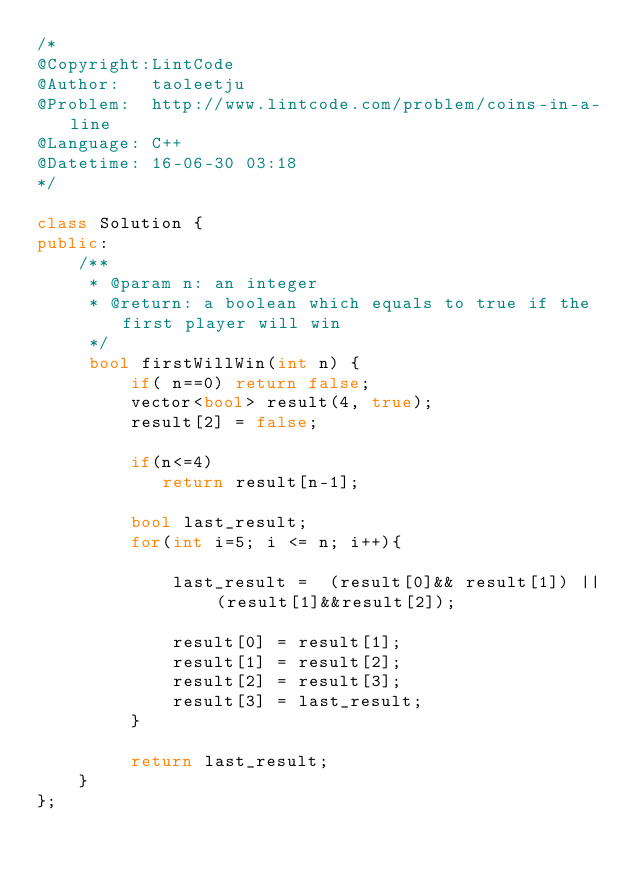<code> <loc_0><loc_0><loc_500><loc_500><_C++_>/*
@Copyright:LintCode
@Author:   taoleetju
@Problem:  http://www.lintcode.com/problem/coins-in-a-line
@Language: C++
@Datetime: 16-06-30 03:18
*/

class Solution {
public:
    /**
     * @param n: an integer
     * @return: a boolean which equals to true if the first player will win
     */
     bool firstWillWin(int n) {
         if( n==0) return false;
         vector<bool> result(4, true);
         result[2] = false;
        
         if(n<=4)
            return result[n-1];
        
         bool last_result;
         for(int i=5; i <= n; i++){
             
             last_result =  (result[0]&& result[1]) || (result[1]&&result[2]);
             
             result[0] = result[1];
             result[1] = result[2];
             result[2] = result[3];
             result[3] = last_result;
         }
         
         return last_result;
    }
};</code> 